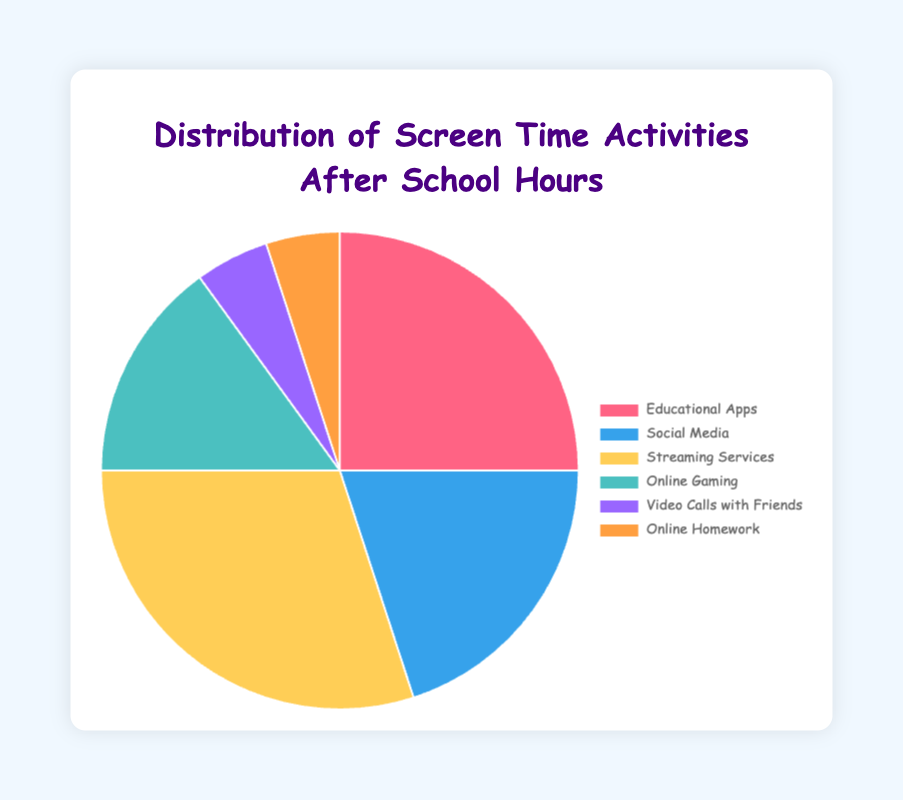Which activity occupies the largest percentage of screen time? The chart shows that "Streaming Services" has the highest percentage of screen time at 30%.
Answer: Streaming Services Which two activities have the same percentage of screen time? The chart shows that both "Video Calls with Friends" and "Online Homework" occupy 5% each of the screen time.
Answer: Video Calls with Friends and Online Homework What is the total percentage of screen time for Social Media and Online Gaming combined? "Social Media" has 20% and "Online Gaming" has 15%. Adding these together gives 20% + 15% = 35%.
Answer: 35% How much more percentage is spent on Streaming Services compared to Educational Apps? Streaming Services has 30%, while Educational Apps has 25%. The difference is 30% - 25% = 5%.
Answer: 5% Which activity uses the least amount of screen time? The chart shows that both "Video Calls with Friends" and "Online Homework" have the least screen time at 5% each.
Answer: Video Calls with Friends and Online Homework What is the combined percentage of screen time spent on activities related to education (Educational Apps and Online Homework)? Educational Apps has 25% and Online Homework has 5%. Adding these together gives 25% + 5% = 30%.
Answer: 30% If a child spends 4 hours on screen activities after school, how much time is spent on Social Media? Social Media occupies 20% of screen time. 20% of 4 hours is (20/100) * 4 = 0.8 hours, which is 48 minutes.
Answer: 48 minutes Is more screen time spent on Online Gaming or Social Media? By how much? The chart shows that Social Media has 20% and Online Gaming has 15%. Social Media takes 5% more screen time than Online Gaming.
Answer: Social Media, 5% What is the combined percentage of screen time for the top three activities? The top three activities are "Streaming Services" (30%), "Educational Apps" (25%), and "Social Media" (20%). Adding these together gives 30% + 25% + 20% = 75%.
Answer: 75% 